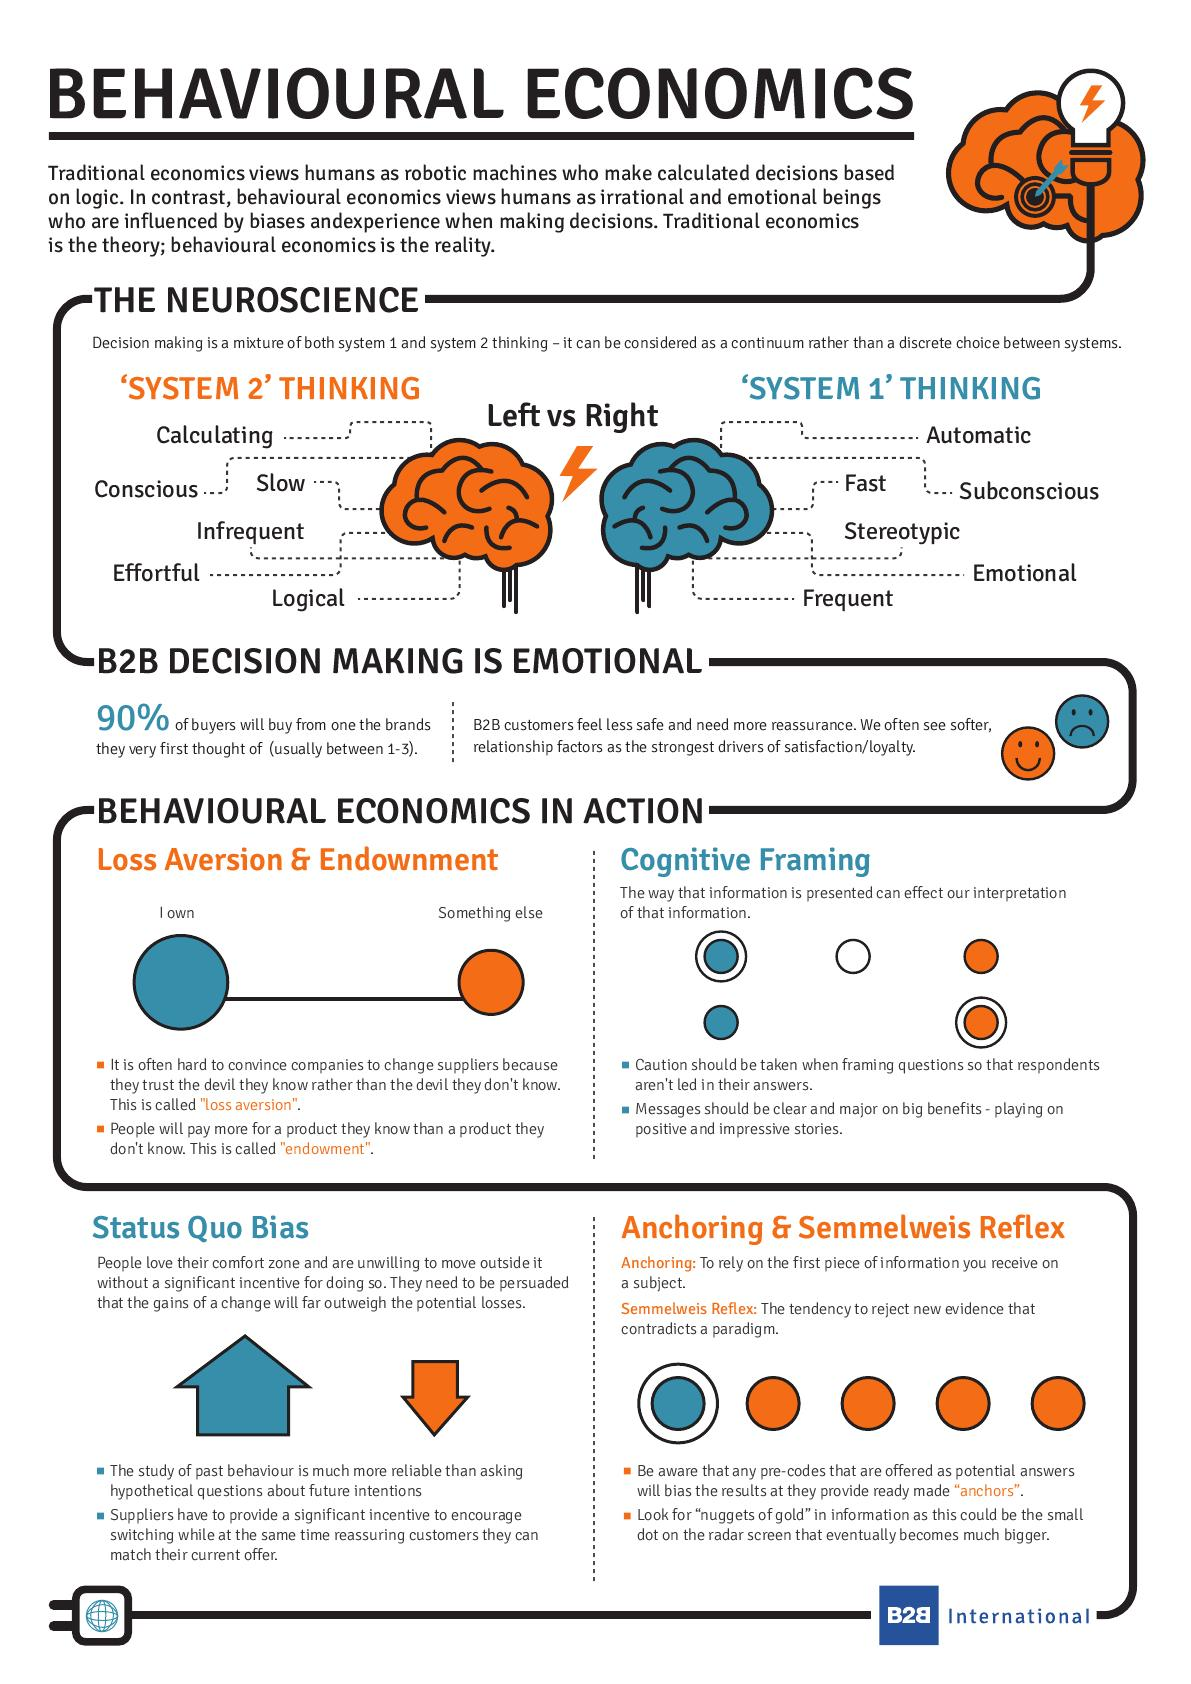Mention a couple of crucial points in this snapshot. The left side of the brain is considered to be part of System 2 Thinking. Approximately 10% of buyers do not purchase items from a brand that they thought about first. The right side of the brain is considered to be associated with System 1 thinking. Six features of System 2 Thinking have been listed. The behavioral patterns characterized by frequent and automatic responses are under the purview of System 1 thinking. 